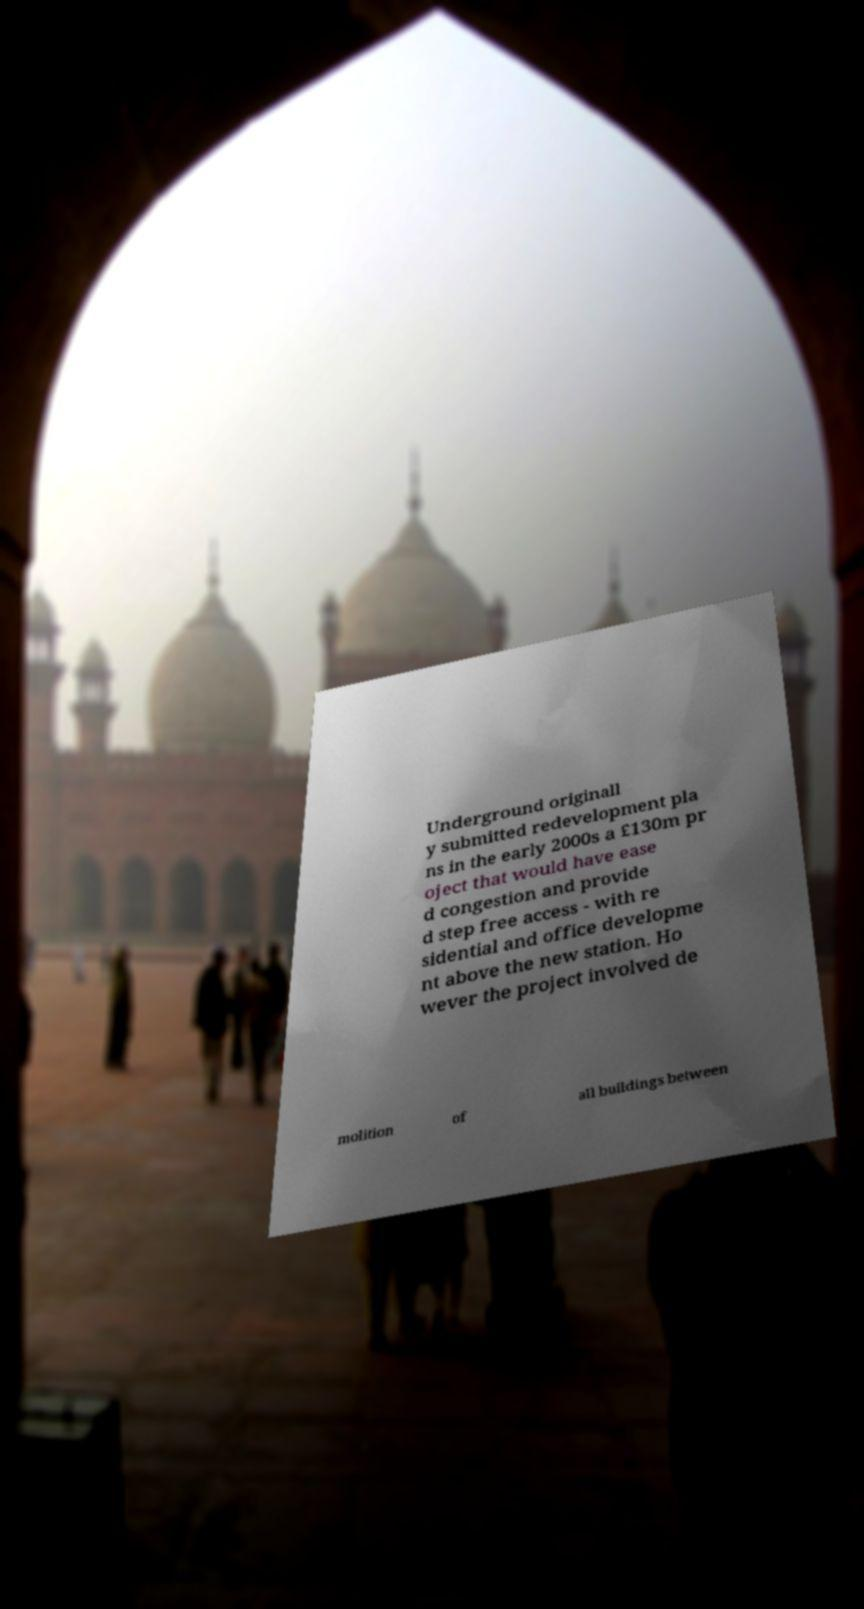Please identify and transcribe the text found in this image. Underground originall y submitted redevelopment pla ns in the early 2000s a £130m pr oject that would have ease d congestion and provide d step free access - with re sidential and office developme nt above the new station. Ho wever the project involved de molition of all buildings between 